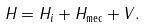Convert formula to latex. <formula><loc_0><loc_0><loc_500><loc_500>H = H _ { i } + H _ { \text {mec} } + V .</formula> 